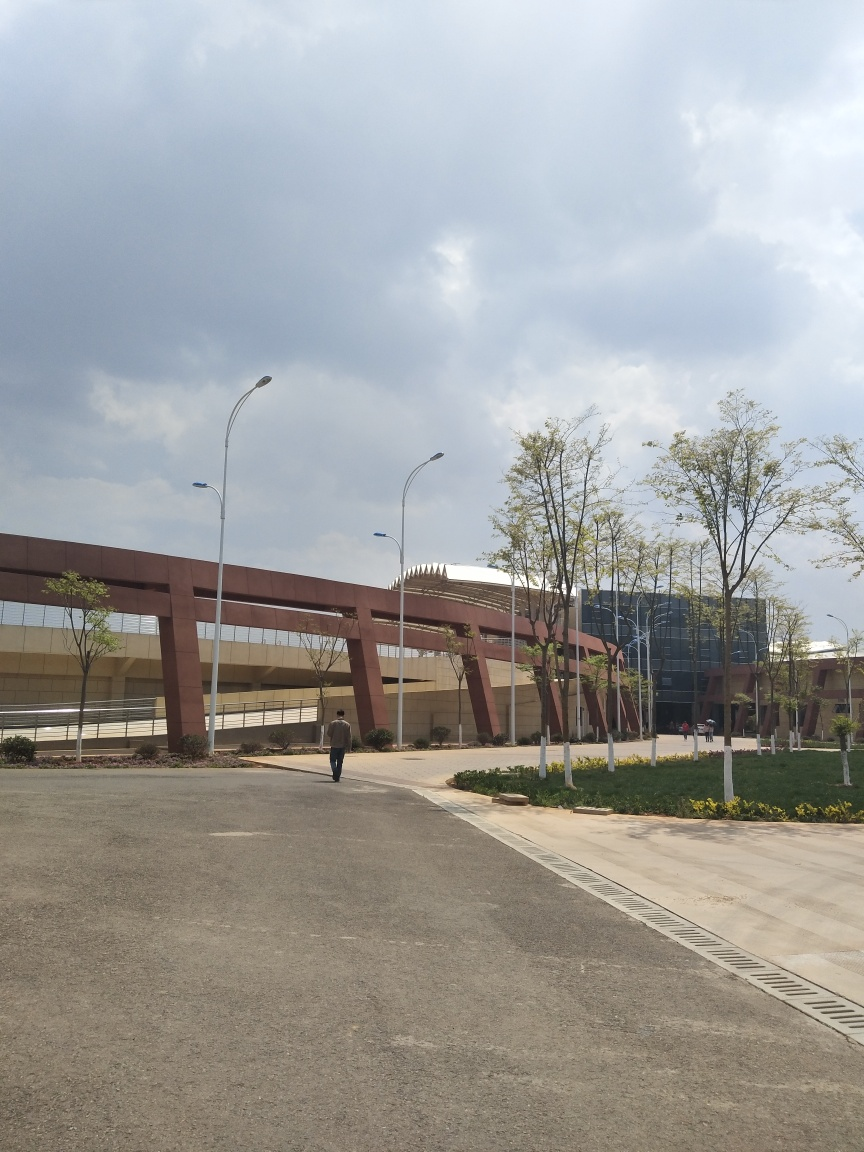Can you tell me about the weather conditions in this image? The photo depicts a day with a mix of cloud cover and clear skies, which likely means that the weather is partly cloudy. The presence of greenery and absence of people wearing heavy clothing suggests it's probably a mild or warm day. 